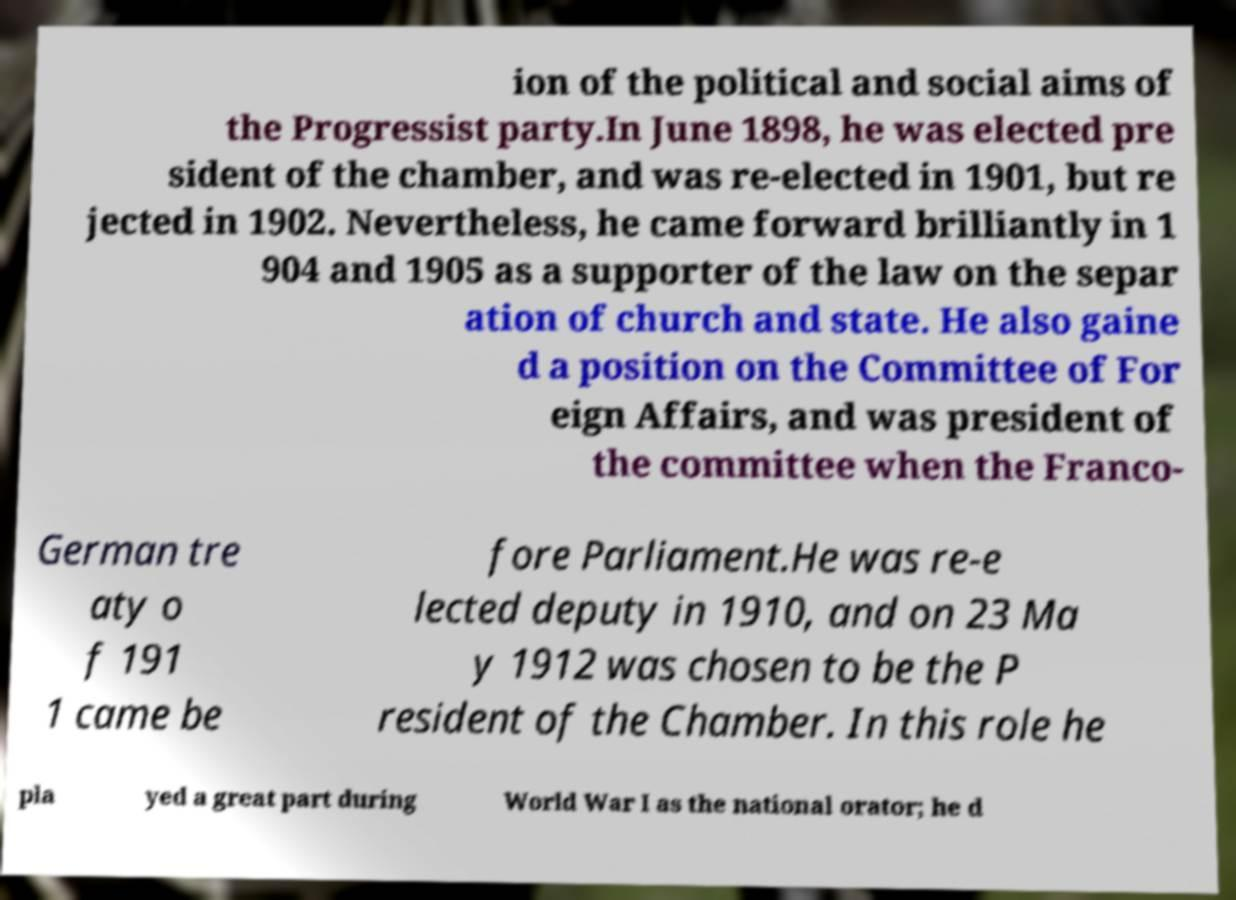For documentation purposes, I need the text within this image transcribed. Could you provide that? ion of the political and social aims of the Progressist party.In June 1898, he was elected pre sident of the chamber, and was re-elected in 1901, but re jected in 1902. Nevertheless, he came forward brilliantly in 1 904 and 1905 as a supporter of the law on the separ ation of church and state. He also gaine d a position on the Committee of For eign Affairs, and was president of the committee when the Franco- German tre aty o f 191 1 came be fore Parliament.He was re-e lected deputy in 1910, and on 23 Ma y 1912 was chosen to be the P resident of the Chamber. In this role he pla yed a great part during World War I as the national orator; he d 